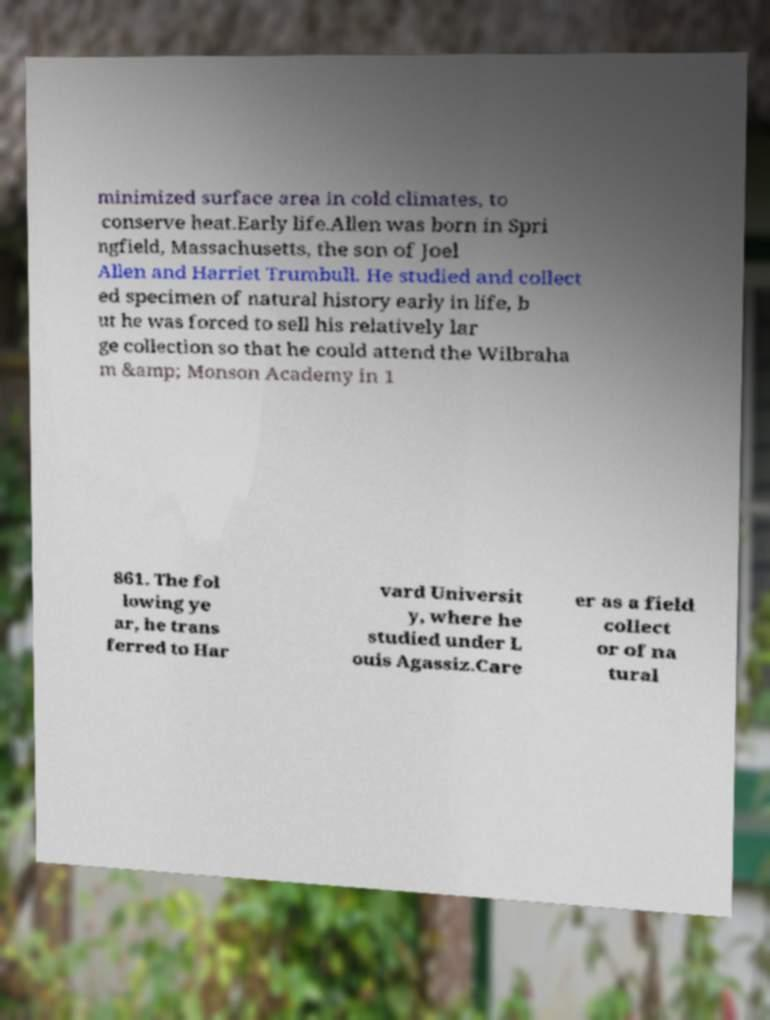For documentation purposes, I need the text within this image transcribed. Could you provide that? minimized surface area in cold climates, to conserve heat.Early life.Allen was born in Spri ngfield, Massachusetts, the son of Joel Allen and Harriet Trumbull. He studied and collect ed specimen of natural history early in life, b ut he was forced to sell his relatively lar ge collection so that he could attend the Wilbraha m &amp; Monson Academy in 1 861. The fol lowing ye ar, he trans ferred to Har vard Universit y, where he studied under L ouis Agassiz.Care er as a field collect or of na tural 